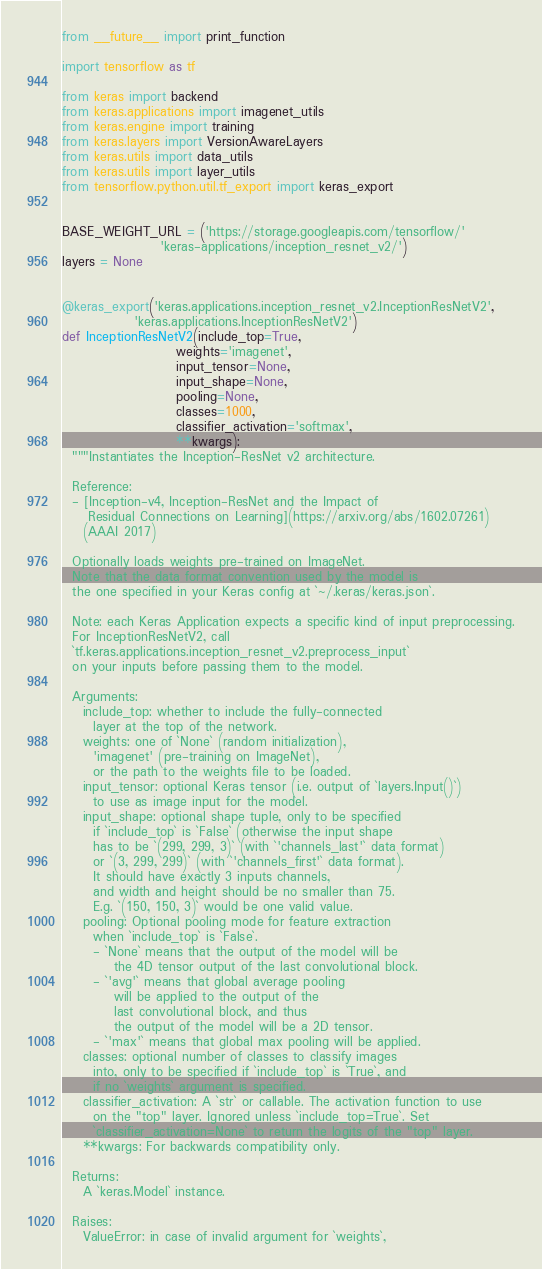<code> <loc_0><loc_0><loc_500><loc_500><_Python_>from __future__ import print_function

import tensorflow as tf

from keras import backend
from keras.applications import imagenet_utils
from keras.engine import training
from keras.layers import VersionAwareLayers
from keras.utils import data_utils
from keras.utils import layer_utils
from tensorflow.python.util.tf_export import keras_export


BASE_WEIGHT_URL = ('https://storage.googleapis.com/tensorflow/'
                   'keras-applications/inception_resnet_v2/')
layers = None


@keras_export('keras.applications.inception_resnet_v2.InceptionResNetV2',
              'keras.applications.InceptionResNetV2')
def InceptionResNetV2(include_top=True,
                      weights='imagenet',
                      input_tensor=None,
                      input_shape=None,
                      pooling=None,
                      classes=1000,
                      classifier_activation='softmax',
                      **kwargs):
  """Instantiates the Inception-ResNet v2 architecture.

  Reference:
  - [Inception-v4, Inception-ResNet and the Impact of
     Residual Connections on Learning](https://arxiv.org/abs/1602.07261)
    (AAAI 2017)

  Optionally loads weights pre-trained on ImageNet.
  Note that the data format convention used by the model is
  the one specified in your Keras config at `~/.keras/keras.json`.

  Note: each Keras Application expects a specific kind of input preprocessing.
  For InceptionResNetV2, call
  `tf.keras.applications.inception_resnet_v2.preprocess_input`
  on your inputs before passing them to the model.

  Arguments:
    include_top: whether to include the fully-connected
      layer at the top of the network.
    weights: one of `None` (random initialization),
      'imagenet' (pre-training on ImageNet),
      or the path to the weights file to be loaded.
    input_tensor: optional Keras tensor (i.e. output of `layers.Input()`)
      to use as image input for the model.
    input_shape: optional shape tuple, only to be specified
      if `include_top` is `False` (otherwise the input shape
      has to be `(299, 299, 3)` (with `'channels_last'` data format)
      or `(3, 299, 299)` (with `'channels_first'` data format).
      It should have exactly 3 inputs channels,
      and width and height should be no smaller than 75.
      E.g. `(150, 150, 3)` would be one valid value.
    pooling: Optional pooling mode for feature extraction
      when `include_top` is `False`.
      - `None` means that the output of the model will be
          the 4D tensor output of the last convolutional block.
      - `'avg'` means that global average pooling
          will be applied to the output of the
          last convolutional block, and thus
          the output of the model will be a 2D tensor.
      - `'max'` means that global max pooling will be applied.
    classes: optional number of classes to classify images
      into, only to be specified if `include_top` is `True`, and
      if no `weights` argument is specified.
    classifier_activation: A `str` or callable. The activation function to use
      on the "top" layer. Ignored unless `include_top=True`. Set
      `classifier_activation=None` to return the logits of the "top" layer.
    **kwargs: For backwards compatibility only.

  Returns:
    A `keras.Model` instance.

  Raises:
    ValueError: in case of invalid argument for `weights`,</code> 